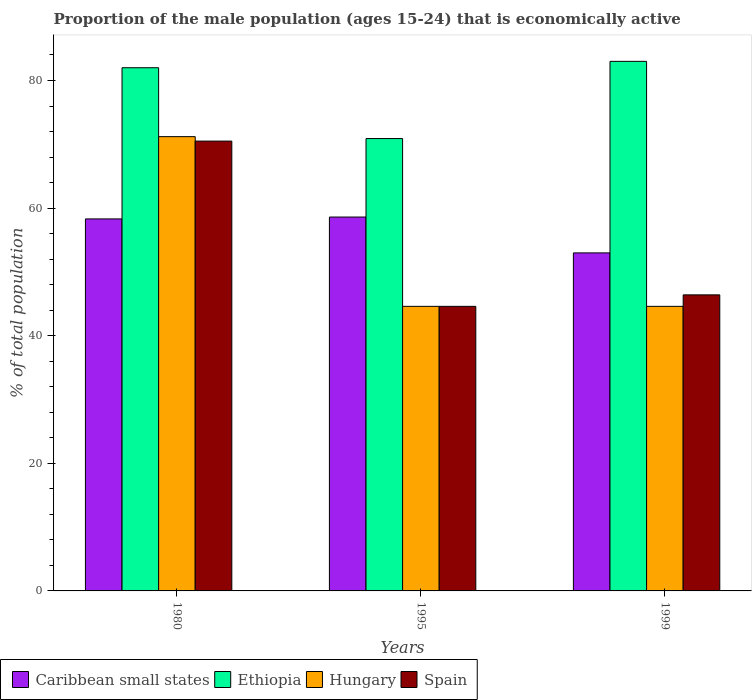How many different coloured bars are there?
Keep it short and to the point. 4. How many groups of bars are there?
Provide a short and direct response. 3. How many bars are there on the 1st tick from the left?
Provide a succinct answer. 4. In how many cases, is the number of bars for a given year not equal to the number of legend labels?
Make the answer very short. 0. What is the proportion of the male population that is economically active in Hungary in 1995?
Provide a short and direct response. 44.6. Across all years, what is the maximum proportion of the male population that is economically active in Ethiopia?
Give a very brief answer. 83. Across all years, what is the minimum proportion of the male population that is economically active in Hungary?
Offer a very short reply. 44.6. What is the total proportion of the male population that is economically active in Spain in the graph?
Offer a very short reply. 161.5. What is the difference between the proportion of the male population that is economically active in Hungary in 1980 and that in 1995?
Provide a short and direct response. 26.6. What is the difference between the proportion of the male population that is economically active in Ethiopia in 1999 and the proportion of the male population that is economically active in Spain in 1980?
Ensure brevity in your answer.  12.5. What is the average proportion of the male population that is economically active in Caribbean small states per year?
Make the answer very short. 56.63. In the year 1980, what is the difference between the proportion of the male population that is economically active in Hungary and proportion of the male population that is economically active in Ethiopia?
Offer a very short reply. -10.8. In how many years, is the proportion of the male population that is economically active in Hungary greater than 44 %?
Give a very brief answer. 3. What is the ratio of the proportion of the male population that is economically active in Caribbean small states in 1980 to that in 1995?
Make the answer very short. 1. Is the difference between the proportion of the male population that is economically active in Hungary in 1995 and 1999 greater than the difference between the proportion of the male population that is economically active in Ethiopia in 1995 and 1999?
Provide a short and direct response. Yes. What is the difference between the highest and the second highest proportion of the male population that is economically active in Ethiopia?
Keep it short and to the point. 1. What is the difference between the highest and the lowest proportion of the male population that is economically active in Hungary?
Provide a succinct answer. 26.6. What does the 1st bar from the left in 1995 represents?
Provide a short and direct response. Caribbean small states. What does the 4th bar from the right in 1999 represents?
Keep it short and to the point. Caribbean small states. How many bars are there?
Give a very brief answer. 12. How many years are there in the graph?
Your answer should be very brief. 3. What is the difference between two consecutive major ticks on the Y-axis?
Ensure brevity in your answer.  20. Are the values on the major ticks of Y-axis written in scientific E-notation?
Give a very brief answer. No. Where does the legend appear in the graph?
Keep it short and to the point. Bottom left. What is the title of the graph?
Offer a terse response. Proportion of the male population (ages 15-24) that is economically active. Does "Belgium" appear as one of the legend labels in the graph?
Your response must be concise. No. What is the label or title of the X-axis?
Your response must be concise. Years. What is the label or title of the Y-axis?
Offer a very short reply. % of total population. What is the % of total population in Caribbean small states in 1980?
Provide a succinct answer. 58.31. What is the % of total population in Ethiopia in 1980?
Keep it short and to the point. 82. What is the % of total population in Hungary in 1980?
Offer a terse response. 71.2. What is the % of total population in Spain in 1980?
Provide a short and direct response. 70.5. What is the % of total population in Caribbean small states in 1995?
Provide a short and direct response. 58.6. What is the % of total population of Ethiopia in 1995?
Ensure brevity in your answer.  70.9. What is the % of total population of Hungary in 1995?
Offer a terse response. 44.6. What is the % of total population of Spain in 1995?
Give a very brief answer. 44.6. What is the % of total population of Caribbean small states in 1999?
Provide a succinct answer. 52.98. What is the % of total population in Ethiopia in 1999?
Keep it short and to the point. 83. What is the % of total population in Hungary in 1999?
Keep it short and to the point. 44.6. What is the % of total population of Spain in 1999?
Your answer should be compact. 46.4. Across all years, what is the maximum % of total population in Caribbean small states?
Ensure brevity in your answer.  58.6. Across all years, what is the maximum % of total population in Hungary?
Offer a very short reply. 71.2. Across all years, what is the maximum % of total population of Spain?
Ensure brevity in your answer.  70.5. Across all years, what is the minimum % of total population of Caribbean small states?
Provide a short and direct response. 52.98. Across all years, what is the minimum % of total population of Ethiopia?
Provide a succinct answer. 70.9. Across all years, what is the minimum % of total population in Hungary?
Your answer should be very brief. 44.6. Across all years, what is the minimum % of total population in Spain?
Your response must be concise. 44.6. What is the total % of total population of Caribbean small states in the graph?
Give a very brief answer. 169.88. What is the total % of total population in Ethiopia in the graph?
Provide a succinct answer. 235.9. What is the total % of total population in Hungary in the graph?
Give a very brief answer. 160.4. What is the total % of total population in Spain in the graph?
Ensure brevity in your answer.  161.5. What is the difference between the % of total population in Caribbean small states in 1980 and that in 1995?
Offer a terse response. -0.29. What is the difference between the % of total population in Ethiopia in 1980 and that in 1995?
Make the answer very short. 11.1. What is the difference between the % of total population in Hungary in 1980 and that in 1995?
Offer a very short reply. 26.6. What is the difference between the % of total population in Spain in 1980 and that in 1995?
Your answer should be compact. 25.9. What is the difference between the % of total population of Caribbean small states in 1980 and that in 1999?
Keep it short and to the point. 5.33. What is the difference between the % of total population of Ethiopia in 1980 and that in 1999?
Make the answer very short. -1. What is the difference between the % of total population of Hungary in 1980 and that in 1999?
Give a very brief answer. 26.6. What is the difference between the % of total population of Spain in 1980 and that in 1999?
Provide a short and direct response. 24.1. What is the difference between the % of total population of Caribbean small states in 1995 and that in 1999?
Offer a terse response. 5.62. What is the difference between the % of total population of Hungary in 1995 and that in 1999?
Provide a short and direct response. 0. What is the difference between the % of total population in Spain in 1995 and that in 1999?
Provide a short and direct response. -1.8. What is the difference between the % of total population of Caribbean small states in 1980 and the % of total population of Ethiopia in 1995?
Provide a succinct answer. -12.59. What is the difference between the % of total population in Caribbean small states in 1980 and the % of total population in Hungary in 1995?
Make the answer very short. 13.71. What is the difference between the % of total population of Caribbean small states in 1980 and the % of total population of Spain in 1995?
Your response must be concise. 13.71. What is the difference between the % of total population in Ethiopia in 1980 and the % of total population in Hungary in 1995?
Give a very brief answer. 37.4. What is the difference between the % of total population of Ethiopia in 1980 and the % of total population of Spain in 1995?
Ensure brevity in your answer.  37.4. What is the difference between the % of total population in Hungary in 1980 and the % of total population in Spain in 1995?
Offer a very short reply. 26.6. What is the difference between the % of total population in Caribbean small states in 1980 and the % of total population in Ethiopia in 1999?
Your response must be concise. -24.69. What is the difference between the % of total population in Caribbean small states in 1980 and the % of total population in Hungary in 1999?
Offer a terse response. 13.71. What is the difference between the % of total population in Caribbean small states in 1980 and the % of total population in Spain in 1999?
Your answer should be compact. 11.91. What is the difference between the % of total population of Ethiopia in 1980 and the % of total population of Hungary in 1999?
Your answer should be compact. 37.4. What is the difference between the % of total population of Ethiopia in 1980 and the % of total population of Spain in 1999?
Provide a succinct answer. 35.6. What is the difference between the % of total population of Hungary in 1980 and the % of total population of Spain in 1999?
Give a very brief answer. 24.8. What is the difference between the % of total population of Caribbean small states in 1995 and the % of total population of Ethiopia in 1999?
Ensure brevity in your answer.  -24.4. What is the difference between the % of total population of Caribbean small states in 1995 and the % of total population of Hungary in 1999?
Your response must be concise. 14. What is the difference between the % of total population of Caribbean small states in 1995 and the % of total population of Spain in 1999?
Offer a very short reply. 12.2. What is the difference between the % of total population of Ethiopia in 1995 and the % of total population of Hungary in 1999?
Offer a terse response. 26.3. What is the difference between the % of total population in Hungary in 1995 and the % of total population in Spain in 1999?
Keep it short and to the point. -1.8. What is the average % of total population in Caribbean small states per year?
Provide a short and direct response. 56.63. What is the average % of total population in Ethiopia per year?
Your response must be concise. 78.63. What is the average % of total population in Hungary per year?
Keep it short and to the point. 53.47. What is the average % of total population in Spain per year?
Keep it short and to the point. 53.83. In the year 1980, what is the difference between the % of total population in Caribbean small states and % of total population in Ethiopia?
Ensure brevity in your answer.  -23.69. In the year 1980, what is the difference between the % of total population of Caribbean small states and % of total population of Hungary?
Your answer should be very brief. -12.89. In the year 1980, what is the difference between the % of total population of Caribbean small states and % of total population of Spain?
Ensure brevity in your answer.  -12.19. In the year 1980, what is the difference between the % of total population in Ethiopia and % of total population in Hungary?
Your answer should be very brief. 10.8. In the year 1980, what is the difference between the % of total population of Ethiopia and % of total population of Spain?
Your answer should be compact. 11.5. In the year 1980, what is the difference between the % of total population in Hungary and % of total population in Spain?
Your answer should be compact. 0.7. In the year 1995, what is the difference between the % of total population in Caribbean small states and % of total population in Ethiopia?
Make the answer very short. -12.3. In the year 1995, what is the difference between the % of total population of Caribbean small states and % of total population of Hungary?
Your answer should be very brief. 14. In the year 1995, what is the difference between the % of total population of Caribbean small states and % of total population of Spain?
Your answer should be compact. 14. In the year 1995, what is the difference between the % of total population in Ethiopia and % of total population in Hungary?
Ensure brevity in your answer.  26.3. In the year 1995, what is the difference between the % of total population of Ethiopia and % of total population of Spain?
Provide a succinct answer. 26.3. In the year 1995, what is the difference between the % of total population in Hungary and % of total population in Spain?
Provide a short and direct response. 0. In the year 1999, what is the difference between the % of total population of Caribbean small states and % of total population of Ethiopia?
Keep it short and to the point. -30.02. In the year 1999, what is the difference between the % of total population in Caribbean small states and % of total population in Hungary?
Your response must be concise. 8.38. In the year 1999, what is the difference between the % of total population in Caribbean small states and % of total population in Spain?
Ensure brevity in your answer.  6.58. In the year 1999, what is the difference between the % of total population of Ethiopia and % of total population of Hungary?
Your answer should be very brief. 38.4. In the year 1999, what is the difference between the % of total population of Ethiopia and % of total population of Spain?
Ensure brevity in your answer.  36.6. What is the ratio of the % of total population in Caribbean small states in 1980 to that in 1995?
Keep it short and to the point. 0.99. What is the ratio of the % of total population in Ethiopia in 1980 to that in 1995?
Offer a terse response. 1.16. What is the ratio of the % of total population in Hungary in 1980 to that in 1995?
Make the answer very short. 1.6. What is the ratio of the % of total population in Spain in 1980 to that in 1995?
Your response must be concise. 1.58. What is the ratio of the % of total population in Caribbean small states in 1980 to that in 1999?
Offer a terse response. 1.1. What is the ratio of the % of total population of Ethiopia in 1980 to that in 1999?
Ensure brevity in your answer.  0.99. What is the ratio of the % of total population of Hungary in 1980 to that in 1999?
Your response must be concise. 1.6. What is the ratio of the % of total population in Spain in 1980 to that in 1999?
Ensure brevity in your answer.  1.52. What is the ratio of the % of total population in Caribbean small states in 1995 to that in 1999?
Keep it short and to the point. 1.11. What is the ratio of the % of total population in Ethiopia in 1995 to that in 1999?
Give a very brief answer. 0.85. What is the ratio of the % of total population of Hungary in 1995 to that in 1999?
Keep it short and to the point. 1. What is the ratio of the % of total population in Spain in 1995 to that in 1999?
Provide a short and direct response. 0.96. What is the difference between the highest and the second highest % of total population of Caribbean small states?
Offer a very short reply. 0.29. What is the difference between the highest and the second highest % of total population of Hungary?
Provide a succinct answer. 26.6. What is the difference between the highest and the second highest % of total population of Spain?
Make the answer very short. 24.1. What is the difference between the highest and the lowest % of total population of Caribbean small states?
Your answer should be compact. 5.62. What is the difference between the highest and the lowest % of total population in Ethiopia?
Provide a short and direct response. 12.1. What is the difference between the highest and the lowest % of total population in Hungary?
Make the answer very short. 26.6. What is the difference between the highest and the lowest % of total population of Spain?
Ensure brevity in your answer.  25.9. 